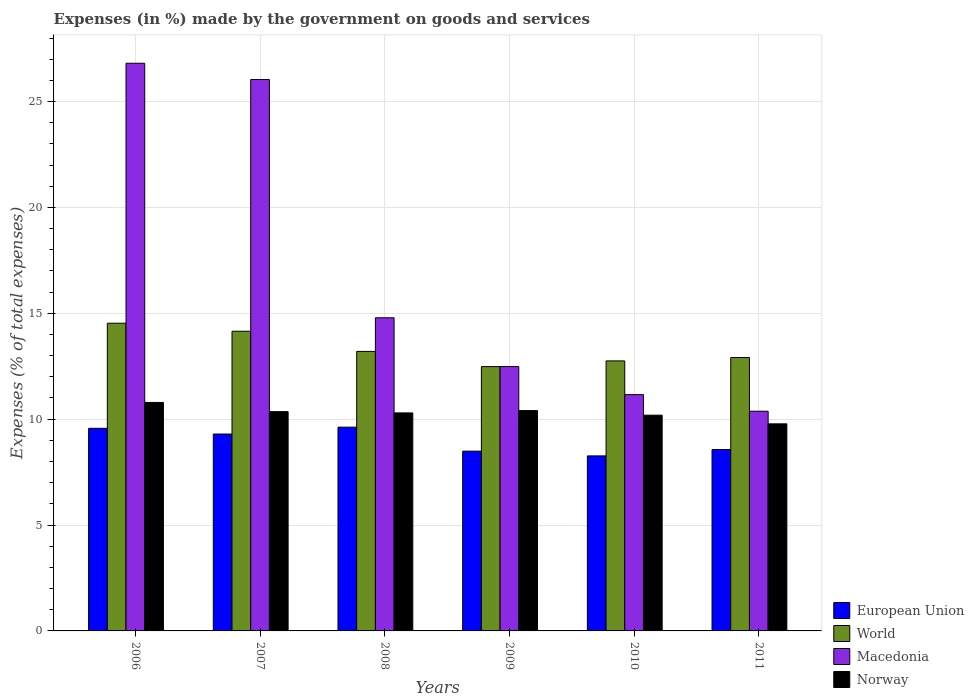How many different coloured bars are there?
Ensure brevity in your answer.  4. How many groups of bars are there?
Your response must be concise. 6. Are the number of bars on each tick of the X-axis equal?
Give a very brief answer. Yes. How many bars are there on the 6th tick from the left?
Make the answer very short. 4. What is the percentage of expenses made by the government on goods and services in Macedonia in 2011?
Keep it short and to the point. 10.38. Across all years, what is the maximum percentage of expenses made by the government on goods and services in European Union?
Keep it short and to the point. 9.62. Across all years, what is the minimum percentage of expenses made by the government on goods and services in World?
Provide a succinct answer. 12.48. In which year was the percentage of expenses made by the government on goods and services in Macedonia maximum?
Ensure brevity in your answer.  2006. What is the total percentage of expenses made by the government on goods and services in World in the graph?
Give a very brief answer. 80.03. What is the difference between the percentage of expenses made by the government on goods and services in European Union in 2006 and that in 2010?
Provide a succinct answer. 1.3. What is the difference between the percentage of expenses made by the government on goods and services in World in 2011 and the percentage of expenses made by the government on goods and services in Norway in 2009?
Provide a succinct answer. 2.51. What is the average percentage of expenses made by the government on goods and services in Macedonia per year?
Give a very brief answer. 16.94. In the year 2006, what is the difference between the percentage of expenses made by the government on goods and services in World and percentage of expenses made by the government on goods and services in Norway?
Provide a short and direct response. 3.74. In how many years, is the percentage of expenses made by the government on goods and services in Norway greater than 3 %?
Give a very brief answer. 6. What is the ratio of the percentage of expenses made by the government on goods and services in World in 2006 to that in 2010?
Make the answer very short. 1.14. Is the percentage of expenses made by the government on goods and services in World in 2008 less than that in 2011?
Your response must be concise. No. Is the difference between the percentage of expenses made by the government on goods and services in World in 2008 and 2010 greater than the difference between the percentage of expenses made by the government on goods and services in Norway in 2008 and 2010?
Make the answer very short. Yes. What is the difference between the highest and the second highest percentage of expenses made by the government on goods and services in Norway?
Keep it short and to the point. 0.38. What is the difference between the highest and the lowest percentage of expenses made by the government on goods and services in World?
Offer a terse response. 2.05. What does the 3rd bar from the left in 2008 represents?
Ensure brevity in your answer.  Macedonia. Is it the case that in every year, the sum of the percentage of expenses made by the government on goods and services in Macedonia and percentage of expenses made by the government on goods and services in European Union is greater than the percentage of expenses made by the government on goods and services in World?
Your answer should be very brief. Yes. Are all the bars in the graph horizontal?
Your answer should be very brief. No. Are the values on the major ticks of Y-axis written in scientific E-notation?
Provide a short and direct response. No. Does the graph contain any zero values?
Offer a very short reply. No. Where does the legend appear in the graph?
Your response must be concise. Bottom right. How many legend labels are there?
Keep it short and to the point. 4. How are the legend labels stacked?
Your answer should be very brief. Vertical. What is the title of the graph?
Make the answer very short. Expenses (in %) made by the government on goods and services. What is the label or title of the Y-axis?
Provide a short and direct response. Expenses (% of total expenses). What is the Expenses (% of total expenses) in European Union in 2006?
Ensure brevity in your answer.  9.57. What is the Expenses (% of total expenses) of World in 2006?
Offer a terse response. 14.53. What is the Expenses (% of total expenses) in Macedonia in 2006?
Offer a very short reply. 26.81. What is the Expenses (% of total expenses) in Norway in 2006?
Make the answer very short. 10.79. What is the Expenses (% of total expenses) of European Union in 2007?
Your answer should be compact. 9.3. What is the Expenses (% of total expenses) of World in 2007?
Give a very brief answer. 14.15. What is the Expenses (% of total expenses) in Macedonia in 2007?
Offer a terse response. 26.04. What is the Expenses (% of total expenses) of Norway in 2007?
Your answer should be compact. 10.36. What is the Expenses (% of total expenses) in European Union in 2008?
Your response must be concise. 9.62. What is the Expenses (% of total expenses) of World in 2008?
Ensure brevity in your answer.  13.2. What is the Expenses (% of total expenses) in Macedonia in 2008?
Offer a very short reply. 14.79. What is the Expenses (% of total expenses) in Norway in 2008?
Your answer should be compact. 10.3. What is the Expenses (% of total expenses) of European Union in 2009?
Make the answer very short. 8.49. What is the Expenses (% of total expenses) in World in 2009?
Your response must be concise. 12.48. What is the Expenses (% of total expenses) in Macedonia in 2009?
Provide a short and direct response. 12.48. What is the Expenses (% of total expenses) of Norway in 2009?
Make the answer very short. 10.41. What is the Expenses (% of total expenses) in European Union in 2010?
Provide a short and direct response. 8.27. What is the Expenses (% of total expenses) of World in 2010?
Give a very brief answer. 12.75. What is the Expenses (% of total expenses) of Macedonia in 2010?
Your answer should be very brief. 11.16. What is the Expenses (% of total expenses) of Norway in 2010?
Your response must be concise. 10.19. What is the Expenses (% of total expenses) of European Union in 2011?
Offer a very short reply. 8.57. What is the Expenses (% of total expenses) in World in 2011?
Give a very brief answer. 12.91. What is the Expenses (% of total expenses) of Macedonia in 2011?
Provide a succinct answer. 10.38. What is the Expenses (% of total expenses) of Norway in 2011?
Your response must be concise. 9.78. Across all years, what is the maximum Expenses (% of total expenses) in European Union?
Offer a terse response. 9.62. Across all years, what is the maximum Expenses (% of total expenses) in World?
Your answer should be compact. 14.53. Across all years, what is the maximum Expenses (% of total expenses) in Macedonia?
Ensure brevity in your answer.  26.81. Across all years, what is the maximum Expenses (% of total expenses) in Norway?
Your answer should be very brief. 10.79. Across all years, what is the minimum Expenses (% of total expenses) of European Union?
Your answer should be very brief. 8.27. Across all years, what is the minimum Expenses (% of total expenses) of World?
Offer a very short reply. 12.48. Across all years, what is the minimum Expenses (% of total expenses) in Macedonia?
Keep it short and to the point. 10.38. Across all years, what is the minimum Expenses (% of total expenses) of Norway?
Offer a very short reply. 9.78. What is the total Expenses (% of total expenses) in European Union in the graph?
Your answer should be very brief. 53.81. What is the total Expenses (% of total expenses) of World in the graph?
Provide a succinct answer. 80.03. What is the total Expenses (% of total expenses) of Macedonia in the graph?
Provide a succinct answer. 101.65. What is the total Expenses (% of total expenses) of Norway in the graph?
Keep it short and to the point. 61.81. What is the difference between the Expenses (% of total expenses) in European Union in 2006 and that in 2007?
Offer a terse response. 0.27. What is the difference between the Expenses (% of total expenses) in World in 2006 and that in 2007?
Provide a short and direct response. 0.38. What is the difference between the Expenses (% of total expenses) in Macedonia in 2006 and that in 2007?
Provide a short and direct response. 0.77. What is the difference between the Expenses (% of total expenses) in Norway in 2006 and that in 2007?
Keep it short and to the point. 0.43. What is the difference between the Expenses (% of total expenses) of European Union in 2006 and that in 2008?
Provide a short and direct response. -0.05. What is the difference between the Expenses (% of total expenses) of World in 2006 and that in 2008?
Give a very brief answer. 1.33. What is the difference between the Expenses (% of total expenses) in Macedonia in 2006 and that in 2008?
Provide a short and direct response. 12.02. What is the difference between the Expenses (% of total expenses) of Norway in 2006 and that in 2008?
Make the answer very short. 0.49. What is the difference between the Expenses (% of total expenses) of European Union in 2006 and that in 2009?
Give a very brief answer. 1.08. What is the difference between the Expenses (% of total expenses) of World in 2006 and that in 2009?
Offer a very short reply. 2.05. What is the difference between the Expenses (% of total expenses) of Macedonia in 2006 and that in 2009?
Offer a very short reply. 14.33. What is the difference between the Expenses (% of total expenses) of Norway in 2006 and that in 2009?
Provide a succinct answer. 0.38. What is the difference between the Expenses (% of total expenses) in European Union in 2006 and that in 2010?
Offer a very short reply. 1.3. What is the difference between the Expenses (% of total expenses) in World in 2006 and that in 2010?
Your answer should be very brief. 1.78. What is the difference between the Expenses (% of total expenses) of Macedonia in 2006 and that in 2010?
Make the answer very short. 15.65. What is the difference between the Expenses (% of total expenses) in Norway in 2006 and that in 2010?
Offer a terse response. 0.6. What is the difference between the Expenses (% of total expenses) in European Union in 2006 and that in 2011?
Provide a succinct answer. 1. What is the difference between the Expenses (% of total expenses) of World in 2006 and that in 2011?
Offer a very short reply. 1.62. What is the difference between the Expenses (% of total expenses) of Macedonia in 2006 and that in 2011?
Keep it short and to the point. 16.43. What is the difference between the Expenses (% of total expenses) in Norway in 2006 and that in 2011?
Provide a short and direct response. 1.01. What is the difference between the Expenses (% of total expenses) of European Union in 2007 and that in 2008?
Make the answer very short. -0.32. What is the difference between the Expenses (% of total expenses) of World in 2007 and that in 2008?
Make the answer very short. 0.95. What is the difference between the Expenses (% of total expenses) in Macedonia in 2007 and that in 2008?
Make the answer very short. 11.25. What is the difference between the Expenses (% of total expenses) in European Union in 2007 and that in 2009?
Offer a very short reply. 0.81. What is the difference between the Expenses (% of total expenses) of World in 2007 and that in 2009?
Your answer should be compact. 1.67. What is the difference between the Expenses (% of total expenses) in Macedonia in 2007 and that in 2009?
Provide a succinct answer. 13.56. What is the difference between the Expenses (% of total expenses) in Norway in 2007 and that in 2009?
Ensure brevity in your answer.  -0.05. What is the difference between the Expenses (% of total expenses) in European Union in 2007 and that in 2010?
Make the answer very short. 1.03. What is the difference between the Expenses (% of total expenses) in World in 2007 and that in 2010?
Offer a very short reply. 1.4. What is the difference between the Expenses (% of total expenses) of Macedonia in 2007 and that in 2010?
Your answer should be very brief. 14.88. What is the difference between the Expenses (% of total expenses) in Norway in 2007 and that in 2010?
Your response must be concise. 0.17. What is the difference between the Expenses (% of total expenses) in European Union in 2007 and that in 2011?
Ensure brevity in your answer.  0.73. What is the difference between the Expenses (% of total expenses) of World in 2007 and that in 2011?
Your response must be concise. 1.24. What is the difference between the Expenses (% of total expenses) in Macedonia in 2007 and that in 2011?
Offer a very short reply. 15.66. What is the difference between the Expenses (% of total expenses) of Norway in 2007 and that in 2011?
Ensure brevity in your answer.  0.58. What is the difference between the Expenses (% of total expenses) in European Union in 2008 and that in 2009?
Ensure brevity in your answer.  1.13. What is the difference between the Expenses (% of total expenses) of World in 2008 and that in 2009?
Your answer should be compact. 0.72. What is the difference between the Expenses (% of total expenses) in Macedonia in 2008 and that in 2009?
Keep it short and to the point. 2.31. What is the difference between the Expenses (% of total expenses) in Norway in 2008 and that in 2009?
Your answer should be compact. -0.11. What is the difference between the Expenses (% of total expenses) in European Union in 2008 and that in 2010?
Your answer should be very brief. 1.36. What is the difference between the Expenses (% of total expenses) in World in 2008 and that in 2010?
Ensure brevity in your answer.  0.45. What is the difference between the Expenses (% of total expenses) of Macedonia in 2008 and that in 2010?
Keep it short and to the point. 3.63. What is the difference between the Expenses (% of total expenses) of Norway in 2008 and that in 2010?
Ensure brevity in your answer.  0.11. What is the difference between the Expenses (% of total expenses) of European Union in 2008 and that in 2011?
Offer a terse response. 1.05. What is the difference between the Expenses (% of total expenses) of World in 2008 and that in 2011?
Your response must be concise. 0.29. What is the difference between the Expenses (% of total expenses) in Macedonia in 2008 and that in 2011?
Your answer should be very brief. 4.41. What is the difference between the Expenses (% of total expenses) of Norway in 2008 and that in 2011?
Offer a terse response. 0.52. What is the difference between the Expenses (% of total expenses) in European Union in 2009 and that in 2010?
Make the answer very short. 0.22. What is the difference between the Expenses (% of total expenses) in World in 2009 and that in 2010?
Provide a succinct answer. -0.27. What is the difference between the Expenses (% of total expenses) in Macedonia in 2009 and that in 2010?
Give a very brief answer. 1.32. What is the difference between the Expenses (% of total expenses) of Norway in 2009 and that in 2010?
Your answer should be very brief. 0.22. What is the difference between the Expenses (% of total expenses) of European Union in 2009 and that in 2011?
Offer a very short reply. -0.08. What is the difference between the Expenses (% of total expenses) of World in 2009 and that in 2011?
Your answer should be very brief. -0.43. What is the difference between the Expenses (% of total expenses) of Macedonia in 2009 and that in 2011?
Offer a very short reply. 2.11. What is the difference between the Expenses (% of total expenses) of Norway in 2009 and that in 2011?
Offer a very short reply. 0.63. What is the difference between the Expenses (% of total expenses) in European Union in 2010 and that in 2011?
Keep it short and to the point. -0.3. What is the difference between the Expenses (% of total expenses) of World in 2010 and that in 2011?
Offer a terse response. -0.16. What is the difference between the Expenses (% of total expenses) in Macedonia in 2010 and that in 2011?
Give a very brief answer. 0.78. What is the difference between the Expenses (% of total expenses) of Norway in 2010 and that in 2011?
Offer a terse response. 0.41. What is the difference between the Expenses (% of total expenses) of European Union in 2006 and the Expenses (% of total expenses) of World in 2007?
Provide a short and direct response. -4.58. What is the difference between the Expenses (% of total expenses) of European Union in 2006 and the Expenses (% of total expenses) of Macedonia in 2007?
Offer a terse response. -16.47. What is the difference between the Expenses (% of total expenses) of European Union in 2006 and the Expenses (% of total expenses) of Norway in 2007?
Your answer should be very brief. -0.79. What is the difference between the Expenses (% of total expenses) in World in 2006 and the Expenses (% of total expenses) in Macedonia in 2007?
Provide a short and direct response. -11.51. What is the difference between the Expenses (% of total expenses) in World in 2006 and the Expenses (% of total expenses) in Norway in 2007?
Offer a very short reply. 4.18. What is the difference between the Expenses (% of total expenses) in Macedonia in 2006 and the Expenses (% of total expenses) in Norway in 2007?
Keep it short and to the point. 16.45. What is the difference between the Expenses (% of total expenses) of European Union in 2006 and the Expenses (% of total expenses) of World in 2008?
Keep it short and to the point. -3.63. What is the difference between the Expenses (% of total expenses) of European Union in 2006 and the Expenses (% of total expenses) of Macedonia in 2008?
Provide a succinct answer. -5.22. What is the difference between the Expenses (% of total expenses) of European Union in 2006 and the Expenses (% of total expenses) of Norway in 2008?
Provide a short and direct response. -0.73. What is the difference between the Expenses (% of total expenses) in World in 2006 and the Expenses (% of total expenses) in Macedonia in 2008?
Ensure brevity in your answer.  -0.26. What is the difference between the Expenses (% of total expenses) of World in 2006 and the Expenses (% of total expenses) of Norway in 2008?
Ensure brevity in your answer.  4.24. What is the difference between the Expenses (% of total expenses) in Macedonia in 2006 and the Expenses (% of total expenses) in Norway in 2008?
Offer a very short reply. 16.51. What is the difference between the Expenses (% of total expenses) in European Union in 2006 and the Expenses (% of total expenses) in World in 2009?
Keep it short and to the point. -2.91. What is the difference between the Expenses (% of total expenses) of European Union in 2006 and the Expenses (% of total expenses) of Macedonia in 2009?
Provide a succinct answer. -2.91. What is the difference between the Expenses (% of total expenses) in European Union in 2006 and the Expenses (% of total expenses) in Norway in 2009?
Ensure brevity in your answer.  -0.84. What is the difference between the Expenses (% of total expenses) of World in 2006 and the Expenses (% of total expenses) of Macedonia in 2009?
Your response must be concise. 2.05. What is the difference between the Expenses (% of total expenses) of World in 2006 and the Expenses (% of total expenses) of Norway in 2009?
Offer a terse response. 4.13. What is the difference between the Expenses (% of total expenses) of Macedonia in 2006 and the Expenses (% of total expenses) of Norway in 2009?
Offer a very short reply. 16.4. What is the difference between the Expenses (% of total expenses) of European Union in 2006 and the Expenses (% of total expenses) of World in 2010?
Offer a very short reply. -3.18. What is the difference between the Expenses (% of total expenses) in European Union in 2006 and the Expenses (% of total expenses) in Macedonia in 2010?
Provide a succinct answer. -1.59. What is the difference between the Expenses (% of total expenses) in European Union in 2006 and the Expenses (% of total expenses) in Norway in 2010?
Provide a succinct answer. -0.62. What is the difference between the Expenses (% of total expenses) in World in 2006 and the Expenses (% of total expenses) in Macedonia in 2010?
Your answer should be very brief. 3.37. What is the difference between the Expenses (% of total expenses) of World in 2006 and the Expenses (% of total expenses) of Norway in 2010?
Your answer should be compact. 4.34. What is the difference between the Expenses (% of total expenses) of Macedonia in 2006 and the Expenses (% of total expenses) of Norway in 2010?
Your response must be concise. 16.62. What is the difference between the Expenses (% of total expenses) in European Union in 2006 and the Expenses (% of total expenses) in World in 2011?
Your response must be concise. -3.34. What is the difference between the Expenses (% of total expenses) in European Union in 2006 and the Expenses (% of total expenses) in Macedonia in 2011?
Your answer should be compact. -0.81. What is the difference between the Expenses (% of total expenses) of European Union in 2006 and the Expenses (% of total expenses) of Norway in 2011?
Your answer should be compact. -0.21. What is the difference between the Expenses (% of total expenses) of World in 2006 and the Expenses (% of total expenses) of Macedonia in 2011?
Provide a short and direct response. 4.16. What is the difference between the Expenses (% of total expenses) in World in 2006 and the Expenses (% of total expenses) in Norway in 2011?
Ensure brevity in your answer.  4.75. What is the difference between the Expenses (% of total expenses) in Macedonia in 2006 and the Expenses (% of total expenses) in Norway in 2011?
Ensure brevity in your answer.  17.03. What is the difference between the Expenses (% of total expenses) in European Union in 2007 and the Expenses (% of total expenses) in World in 2008?
Offer a terse response. -3.9. What is the difference between the Expenses (% of total expenses) in European Union in 2007 and the Expenses (% of total expenses) in Macedonia in 2008?
Offer a very short reply. -5.49. What is the difference between the Expenses (% of total expenses) in European Union in 2007 and the Expenses (% of total expenses) in Norway in 2008?
Provide a succinct answer. -1. What is the difference between the Expenses (% of total expenses) in World in 2007 and the Expenses (% of total expenses) in Macedonia in 2008?
Your response must be concise. -0.64. What is the difference between the Expenses (% of total expenses) in World in 2007 and the Expenses (% of total expenses) in Norway in 2008?
Provide a succinct answer. 3.86. What is the difference between the Expenses (% of total expenses) in Macedonia in 2007 and the Expenses (% of total expenses) in Norway in 2008?
Ensure brevity in your answer.  15.74. What is the difference between the Expenses (% of total expenses) in European Union in 2007 and the Expenses (% of total expenses) in World in 2009?
Your response must be concise. -3.18. What is the difference between the Expenses (% of total expenses) in European Union in 2007 and the Expenses (% of total expenses) in Macedonia in 2009?
Provide a short and direct response. -3.18. What is the difference between the Expenses (% of total expenses) of European Union in 2007 and the Expenses (% of total expenses) of Norway in 2009?
Provide a succinct answer. -1.11. What is the difference between the Expenses (% of total expenses) in World in 2007 and the Expenses (% of total expenses) in Macedonia in 2009?
Your answer should be very brief. 1.67. What is the difference between the Expenses (% of total expenses) of World in 2007 and the Expenses (% of total expenses) of Norway in 2009?
Ensure brevity in your answer.  3.75. What is the difference between the Expenses (% of total expenses) in Macedonia in 2007 and the Expenses (% of total expenses) in Norway in 2009?
Keep it short and to the point. 15.63. What is the difference between the Expenses (% of total expenses) in European Union in 2007 and the Expenses (% of total expenses) in World in 2010?
Give a very brief answer. -3.45. What is the difference between the Expenses (% of total expenses) of European Union in 2007 and the Expenses (% of total expenses) of Macedonia in 2010?
Provide a succinct answer. -1.86. What is the difference between the Expenses (% of total expenses) of European Union in 2007 and the Expenses (% of total expenses) of Norway in 2010?
Provide a short and direct response. -0.89. What is the difference between the Expenses (% of total expenses) in World in 2007 and the Expenses (% of total expenses) in Macedonia in 2010?
Provide a succinct answer. 2.99. What is the difference between the Expenses (% of total expenses) of World in 2007 and the Expenses (% of total expenses) of Norway in 2010?
Ensure brevity in your answer.  3.96. What is the difference between the Expenses (% of total expenses) in Macedonia in 2007 and the Expenses (% of total expenses) in Norway in 2010?
Offer a terse response. 15.85. What is the difference between the Expenses (% of total expenses) of European Union in 2007 and the Expenses (% of total expenses) of World in 2011?
Offer a terse response. -3.61. What is the difference between the Expenses (% of total expenses) of European Union in 2007 and the Expenses (% of total expenses) of Macedonia in 2011?
Provide a succinct answer. -1.08. What is the difference between the Expenses (% of total expenses) in European Union in 2007 and the Expenses (% of total expenses) in Norway in 2011?
Make the answer very short. -0.48. What is the difference between the Expenses (% of total expenses) of World in 2007 and the Expenses (% of total expenses) of Macedonia in 2011?
Provide a succinct answer. 3.78. What is the difference between the Expenses (% of total expenses) in World in 2007 and the Expenses (% of total expenses) in Norway in 2011?
Give a very brief answer. 4.37. What is the difference between the Expenses (% of total expenses) in Macedonia in 2007 and the Expenses (% of total expenses) in Norway in 2011?
Offer a terse response. 16.26. What is the difference between the Expenses (% of total expenses) in European Union in 2008 and the Expenses (% of total expenses) in World in 2009?
Your answer should be very brief. -2.86. What is the difference between the Expenses (% of total expenses) of European Union in 2008 and the Expenses (% of total expenses) of Macedonia in 2009?
Offer a very short reply. -2.86. What is the difference between the Expenses (% of total expenses) of European Union in 2008 and the Expenses (% of total expenses) of Norway in 2009?
Ensure brevity in your answer.  -0.78. What is the difference between the Expenses (% of total expenses) of World in 2008 and the Expenses (% of total expenses) of Macedonia in 2009?
Your answer should be very brief. 0.72. What is the difference between the Expenses (% of total expenses) in World in 2008 and the Expenses (% of total expenses) in Norway in 2009?
Keep it short and to the point. 2.79. What is the difference between the Expenses (% of total expenses) in Macedonia in 2008 and the Expenses (% of total expenses) in Norway in 2009?
Offer a terse response. 4.38. What is the difference between the Expenses (% of total expenses) in European Union in 2008 and the Expenses (% of total expenses) in World in 2010?
Offer a terse response. -3.13. What is the difference between the Expenses (% of total expenses) in European Union in 2008 and the Expenses (% of total expenses) in Macedonia in 2010?
Offer a very short reply. -1.54. What is the difference between the Expenses (% of total expenses) of European Union in 2008 and the Expenses (% of total expenses) of Norway in 2010?
Provide a short and direct response. -0.57. What is the difference between the Expenses (% of total expenses) of World in 2008 and the Expenses (% of total expenses) of Macedonia in 2010?
Your answer should be very brief. 2.04. What is the difference between the Expenses (% of total expenses) of World in 2008 and the Expenses (% of total expenses) of Norway in 2010?
Keep it short and to the point. 3.01. What is the difference between the Expenses (% of total expenses) of Macedonia in 2008 and the Expenses (% of total expenses) of Norway in 2010?
Offer a very short reply. 4.6. What is the difference between the Expenses (% of total expenses) of European Union in 2008 and the Expenses (% of total expenses) of World in 2011?
Provide a succinct answer. -3.29. What is the difference between the Expenses (% of total expenses) in European Union in 2008 and the Expenses (% of total expenses) in Macedonia in 2011?
Make the answer very short. -0.75. What is the difference between the Expenses (% of total expenses) of European Union in 2008 and the Expenses (% of total expenses) of Norway in 2011?
Your response must be concise. -0.16. What is the difference between the Expenses (% of total expenses) of World in 2008 and the Expenses (% of total expenses) of Macedonia in 2011?
Keep it short and to the point. 2.82. What is the difference between the Expenses (% of total expenses) of World in 2008 and the Expenses (% of total expenses) of Norway in 2011?
Keep it short and to the point. 3.42. What is the difference between the Expenses (% of total expenses) in Macedonia in 2008 and the Expenses (% of total expenses) in Norway in 2011?
Offer a very short reply. 5.01. What is the difference between the Expenses (% of total expenses) in European Union in 2009 and the Expenses (% of total expenses) in World in 2010?
Keep it short and to the point. -4.26. What is the difference between the Expenses (% of total expenses) in European Union in 2009 and the Expenses (% of total expenses) in Macedonia in 2010?
Your answer should be compact. -2.67. What is the difference between the Expenses (% of total expenses) in European Union in 2009 and the Expenses (% of total expenses) in Norway in 2010?
Offer a very short reply. -1.7. What is the difference between the Expenses (% of total expenses) in World in 2009 and the Expenses (% of total expenses) in Macedonia in 2010?
Provide a short and direct response. 1.32. What is the difference between the Expenses (% of total expenses) in World in 2009 and the Expenses (% of total expenses) in Norway in 2010?
Provide a short and direct response. 2.29. What is the difference between the Expenses (% of total expenses) in Macedonia in 2009 and the Expenses (% of total expenses) in Norway in 2010?
Ensure brevity in your answer.  2.29. What is the difference between the Expenses (% of total expenses) of European Union in 2009 and the Expenses (% of total expenses) of World in 2011?
Provide a succinct answer. -4.42. What is the difference between the Expenses (% of total expenses) of European Union in 2009 and the Expenses (% of total expenses) of Macedonia in 2011?
Offer a very short reply. -1.89. What is the difference between the Expenses (% of total expenses) of European Union in 2009 and the Expenses (% of total expenses) of Norway in 2011?
Provide a succinct answer. -1.29. What is the difference between the Expenses (% of total expenses) in World in 2009 and the Expenses (% of total expenses) in Macedonia in 2011?
Provide a short and direct response. 2.11. What is the difference between the Expenses (% of total expenses) of World in 2009 and the Expenses (% of total expenses) of Norway in 2011?
Provide a short and direct response. 2.7. What is the difference between the Expenses (% of total expenses) in Macedonia in 2009 and the Expenses (% of total expenses) in Norway in 2011?
Make the answer very short. 2.7. What is the difference between the Expenses (% of total expenses) of European Union in 2010 and the Expenses (% of total expenses) of World in 2011?
Ensure brevity in your answer.  -4.65. What is the difference between the Expenses (% of total expenses) in European Union in 2010 and the Expenses (% of total expenses) in Macedonia in 2011?
Offer a very short reply. -2.11. What is the difference between the Expenses (% of total expenses) in European Union in 2010 and the Expenses (% of total expenses) in Norway in 2011?
Provide a short and direct response. -1.51. What is the difference between the Expenses (% of total expenses) of World in 2010 and the Expenses (% of total expenses) of Macedonia in 2011?
Make the answer very short. 2.38. What is the difference between the Expenses (% of total expenses) in World in 2010 and the Expenses (% of total expenses) in Norway in 2011?
Provide a short and direct response. 2.97. What is the difference between the Expenses (% of total expenses) of Macedonia in 2010 and the Expenses (% of total expenses) of Norway in 2011?
Keep it short and to the point. 1.38. What is the average Expenses (% of total expenses) in European Union per year?
Keep it short and to the point. 8.97. What is the average Expenses (% of total expenses) in World per year?
Your answer should be compact. 13.34. What is the average Expenses (% of total expenses) in Macedonia per year?
Your answer should be very brief. 16.94. What is the average Expenses (% of total expenses) in Norway per year?
Provide a succinct answer. 10.3. In the year 2006, what is the difference between the Expenses (% of total expenses) of European Union and Expenses (% of total expenses) of World?
Provide a short and direct response. -4.96. In the year 2006, what is the difference between the Expenses (% of total expenses) in European Union and Expenses (% of total expenses) in Macedonia?
Give a very brief answer. -17.24. In the year 2006, what is the difference between the Expenses (% of total expenses) of European Union and Expenses (% of total expenses) of Norway?
Make the answer very short. -1.22. In the year 2006, what is the difference between the Expenses (% of total expenses) in World and Expenses (% of total expenses) in Macedonia?
Ensure brevity in your answer.  -12.28. In the year 2006, what is the difference between the Expenses (% of total expenses) of World and Expenses (% of total expenses) of Norway?
Make the answer very short. 3.74. In the year 2006, what is the difference between the Expenses (% of total expenses) in Macedonia and Expenses (% of total expenses) in Norway?
Give a very brief answer. 16.02. In the year 2007, what is the difference between the Expenses (% of total expenses) of European Union and Expenses (% of total expenses) of World?
Ensure brevity in your answer.  -4.85. In the year 2007, what is the difference between the Expenses (% of total expenses) of European Union and Expenses (% of total expenses) of Macedonia?
Offer a very short reply. -16.74. In the year 2007, what is the difference between the Expenses (% of total expenses) of European Union and Expenses (% of total expenses) of Norway?
Provide a short and direct response. -1.06. In the year 2007, what is the difference between the Expenses (% of total expenses) of World and Expenses (% of total expenses) of Macedonia?
Provide a short and direct response. -11.89. In the year 2007, what is the difference between the Expenses (% of total expenses) of World and Expenses (% of total expenses) of Norway?
Offer a very short reply. 3.8. In the year 2007, what is the difference between the Expenses (% of total expenses) in Macedonia and Expenses (% of total expenses) in Norway?
Offer a very short reply. 15.68. In the year 2008, what is the difference between the Expenses (% of total expenses) of European Union and Expenses (% of total expenses) of World?
Ensure brevity in your answer.  -3.58. In the year 2008, what is the difference between the Expenses (% of total expenses) in European Union and Expenses (% of total expenses) in Macedonia?
Offer a very short reply. -5.17. In the year 2008, what is the difference between the Expenses (% of total expenses) in European Union and Expenses (% of total expenses) in Norway?
Your response must be concise. -0.67. In the year 2008, what is the difference between the Expenses (% of total expenses) in World and Expenses (% of total expenses) in Macedonia?
Offer a terse response. -1.59. In the year 2008, what is the difference between the Expenses (% of total expenses) in World and Expenses (% of total expenses) in Norway?
Your answer should be compact. 2.9. In the year 2008, what is the difference between the Expenses (% of total expenses) of Macedonia and Expenses (% of total expenses) of Norway?
Offer a very short reply. 4.49. In the year 2009, what is the difference between the Expenses (% of total expenses) in European Union and Expenses (% of total expenses) in World?
Provide a short and direct response. -3.99. In the year 2009, what is the difference between the Expenses (% of total expenses) of European Union and Expenses (% of total expenses) of Macedonia?
Your answer should be compact. -3.99. In the year 2009, what is the difference between the Expenses (% of total expenses) of European Union and Expenses (% of total expenses) of Norway?
Ensure brevity in your answer.  -1.92. In the year 2009, what is the difference between the Expenses (% of total expenses) of World and Expenses (% of total expenses) of Macedonia?
Provide a short and direct response. 0. In the year 2009, what is the difference between the Expenses (% of total expenses) in World and Expenses (% of total expenses) in Norway?
Keep it short and to the point. 2.08. In the year 2009, what is the difference between the Expenses (% of total expenses) of Macedonia and Expenses (% of total expenses) of Norway?
Ensure brevity in your answer.  2.08. In the year 2010, what is the difference between the Expenses (% of total expenses) of European Union and Expenses (% of total expenses) of World?
Provide a succinct answer. -4.49. In the year 2010, what is the difference between the Expenses (% of total expenses) in European Union and Expenses (% of total expenses) in Macedonia?
Your answer should be very brief. -2.89. In the year 2010, what is the difference between the Expenses (% of total expenses) in European Union and Expenses (% of total expenses) in Norway?
Your answer should be compact. -1.92. In the year 2010, what is the difference between the Expenses (% of total expenses) in World and Expenses (% of total expenses) in Macedonia?
Keep it short and to the point. 1.59. In the year 2010, what is the difference between the Expenses (% of total expenses) of World and Expenses (% of total expenses) of Norway?
Offer a terse response. 2.56. In the year 2010, what is the difference between the Expenses (% of total expenses) of Macedonia and Expenses (% of total expenses) of Norway?
Provide a short and direct response. 0.97. In the year 2011, what is the difference between the Expenses (% of total expenses) in European Union and Expenses (% of total expenses) in World?
Your answer should be compact. -4.34. In the year 2011, what is the difference between the Expenses (% of total expenses) of European Union and Expenses (% of total expenses) of Macedonia?
Provide a short and direct response. -1.81. In the year 2011, what is the difference between the Expenses (% of total expenses) of European Union and Expenses (% of total expenses) of Norway?
Keep it short and to the point. -1.21. In the year 2011, what is the difference between the Expenses (% of total expenses) of World and Expenses (% of total expenses) of Macedonia?
Ensure brevity in your answer.  2.54. In the year 2011, what is the difference between the Expenses (% of total expenses) of World and Expenses (% of total expenses) of Norway?
Offer a terse response. 3.13. In the year 2011, what is the difference between the Expenses (% of total expenses) in Macedonia and Expenses (% of total expenses) in Norway?
Provide a short and direct response. 0.6. What is the ratio of the Expenses (% of total expenses) of World in 2006 to that in 2007?
Provide a short and direct response. 1.03. What is the ratio of the Expenses (% of total expenses) in Macedonia in 2006 to that in 2007?
Your answer should be very brief. 1.03. What is the ratio of the Expenses (% of total expenses) of Norway in 2006 to that in 2007?
Provide a succinct answer. 1.04. What is the ratio of the Expenses (% of total expenses) of World in 2006 to that in 2008?
Make the answer very short. 1.1. What is the ratio of the Expenses (% of total expenses) in Macedonia in 2006 to that in 2008?
Keep it short and to the point. 1.81. What is the ratio of the Expenses (% of total expenses) of Norway in 2006 to that in 2008?
Provide a succinct answer. 1.05. What is the ratio of the Expenses (% of total expenses) of European Union in 2006 to that in 2009?
Give a very brief answer. 1.13. What is the ratio of the Expenses (% of total expenses) of World in 2006 to that in 2009?
Provide a succinct answer. 1.16. What is the ratio of the Expenses (% of total expenses) of Macedonia in 2006 to that in 2009?
Your answer should be very brief. 2.15. What is the ratio of the Expenses (% of total expenses) of Norway in 2006 to that in 2009?
Your answer should be compact. 1.04. What is the ratio of the Expenses (% of total expenses) in European Union in 2006 to that in 2010?
Offer a very short reply. 1.16. What is the ratio of the Expenses (% of total expenses) in World in 2006 to that in 2010?
Offer a very short reply. 1.14. What is the ratio of the Expenses (% of total expenses) of Macedonia in 2006 to that in 2010?
Offer a very short reply. 2.4. What is the ratio of the Expenses (% of total expenses) in Norway in 2006 to that in 2010?
Give a very brief answer. 1.06. What is the ratio of the Expenses (% of total expenses) in European Union in 2006 to that in 2011?
Offer a terse response. 1.12. What is the ratio of the Expenses (% of total expenses) of World in 2006 to that in 2011?
Keep it short and to the point. 1.13. What is the ratio of the Expenses (% of total expenses) of Macedonia in 2006 to that in 2011?
Offer a very short reply. 2.58. What is the ratio of the Expenses (% of total expenses) of Norway in 2006 to that in 2011?
Offer a terse response. 1.1. What is the ratio of the Expenses (% of total expenses) of European Union in 2007 to that in 2008?
Offer a very short reply. 0.97. What is the ratio of the Expenses (% of total expenses) in World in 2007 to that in 2008?
Offer a terse response. 1.07. What is the ratio of the Expenses (% of total expenses) in Macedonia in 2007 to that in 2008?
Provide a short and direct response. 1.76. What is the ratio of the Expenses (% of total expenses) in European Union in 2007 to that in 2009?
Your answer should be compact. 1.1. What is the ratio of the Expenses (% of total expenses) in World in 2007 to that in 2009?
Make the answer very short. 1.13. What is the ratio of the Expenses (% of total expenses) in Macedonia in 2007 to that in 2009?
Offer a terse response. 2.09. What is the ratio of the Expenses (% of total expenses) of Norway in 2007 to that in 2009?
Provide a short and direct response. 1. What is the ratio of the Expenses (% of total expenses) of European Union in 2007 to that in 2010?
Keep it short and to the point. 1.12. What is the ratio of the Expenses (% of total expenses) in World in 2007 to that in 2010?
Your answer should be compact. 1.11. What is the ratio of the Expenses (% of total expenses) in Macedonia in 2007 to that in 2010?
Offer a terse response. 2.33. What is the ratio of the Expenses (% of total expenses) of Norway in 2007 to that in 2010?
Your answer should be very brief. 1.02. What is the ratio of the Expenses (% of total expenses) of European Union in 2007 to that in 2011?
Provide a succinct answer. 1.09. What is the ratio of the Expenses (% of total expenses) of World in 2007 to that in 2011?
Provide a succinct answer. 1.1. What is the ratio of the Expenses (% of total expenses) in Macedonia in 2007 to that in 2011?
Provide a short and direct response. 2.51. What is the ratio of the Expenses (% of total expenses) of Norway in 2007 to that in 2011?
Offer a very short reply. 1.06. What is the ratio of the Expenses (% of total expenses) in European Union in 2008 to that in 2009?
Provide a succinct answer. 1.13. What is the ratio of the Expenses (% of total expenses) in World in 2008 to that in 2009?
Provide a succinct answer. 1.06. What is the ratio of the Expenses (% of total expenses) of Macedonia in 2008 to that in 2009?
Offer a terse response. 1.18. What is the ratio of the Expenses (% of total expenses) of Norway in 2008 to that in 2009?
Keep it short and to the point. 0.99. What is the ratio of the Expenses (% of total expenses) in European Union in 2008 to that in 2010?
Make the answer very short. 1.16. What is the ratio of the Expenses (% of total expenses) in World in 2008 to that in 2010?
Your answer should be very brief. 1.04. What is the ratio of the Expenses (% of total expenses) of Macedonia in 2008 to that in 2010?
Provide a short and direct response. 1.33. What is the ratio of the Expenses (% of total expenses) of Norway in 2008 to that in 2010?
Provide a succinct answer. 1.01. What is the ratio of the Expenses (% of total expenses) in European Union in 2008 to that in 2011?
Offer a terse response. 1.12. What is the ratio of the Expenses (% of total expenses) in World in 2008 to that in 2011?
Give a very brief answer. 1.02. What is the ratio of the Expenses (% of total expenses) of Macedonia in 2008 to that in 2011?
Your answer should be compact. 1.43. What is the ratio of the Expenses (% of total expenses) of Norway in 2008 to that in 2011?
Provide a succinct answer. 1.05. What is the ratio of the Expenses (% of total expenses) of European Union in 2009 to that in 2010?
Offer a very short reply. 1.03. What is the ratio of the Expenses (% of total expenses) in World in 2009 to that in 2010?
Offer a terse response. 0.98. What is the ratio of the Expenses (% of total expenses) in Macedonia in 2009 to that in 2010?
Give a very brief answer. 1.12. What is the ratio of the Expenses (% of total expenses) of Norway in 2009 to that in 2010?
Give a very brief answer. 1.02. What is the ratio of the Expenses (% of total expenses) in European Union in 2009 to that in 2011?
Offer a very short reply. 0.99. What is the ratio of the Expenses (% of total expenses) of World in 2009 to that in 2011?
Provide a short and direct response. 0.97. What is the ratio of the Expenses (% of total expenses) in Macedonia in 2009 to that in 2011?
Offer a terse response. 1.2. What is the ratio of the Expenses (% of total expenses) of Norway in 2009 to that in 2011?
Provide a short and direct response. 1.06. What is the ratio of the Expenses (% of total expenses) of European Union in 2010 to that in 2011?
Your answer should be compact. 0.96. What is the ratio of the Expenses (% of total expenses) of World in 2010 to that in 2011?
Provide a succinct answer. 0.99. What is the ratio of the Expenses (% of total expenses) in Macedonia in 2010 to that in 2011?
Your answer should be very brief. 1.08. What is the ratio of the Expenses (% of total expenses) in Norway in 2010 to that in 2011?
Ensure brevity in your answer.  1.04. What is the difference between the highest and the second highest Expenses (% of total expenses) in European Union?
Make the answer very short. 0.05. What is the difference between the highest and the second highest Expenses (% of total expenses) in World?
Offer a terse response. 0.38. What is the difference between the highest and the second highest Expenses (% of total expenses) of Macedonia?
Your answer should be very brief. 0.77. What is the difference between the highest and the second highest Expenses (% of total expenses) in Norway?
Ensure brevity in your answer.  0.38. What is the difference between the highest and the lowest Expenses (% of total expenses) in European Union?
Give a very brief answer. 1.36. What is the difference between the highest and the lowest Expenses (% of total expenses) in World?
Provide a succinct answer. 2.05. What is the difference between the highest and the lowest Expenses (% of total expenses) in Macedonia?
Provide a succinct answer. 16.43. What is the difference between the highest and the lowest Expenses (% of total expenses) in Norway?
Offer a terse response. 1.01. 